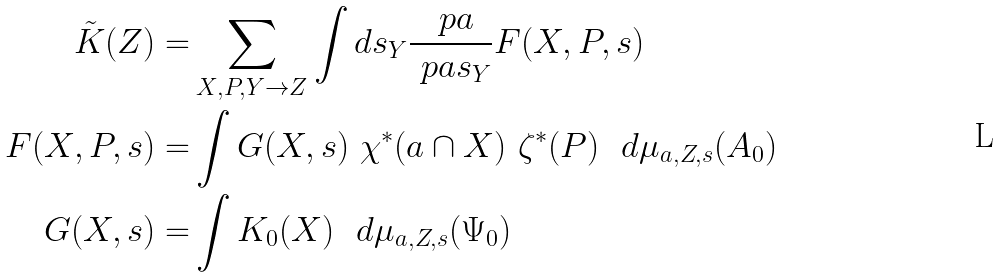Convert formula to latex. <formula><loc_0><loc_0><loc_500><loc_500>\tilde { K } ( Z ) = & \sum _ { X , P , Y \to Z } \int d s _ { Y } \frac { \ p a } { \ p a s _ { Y } } F ( X , P , s ) \\ F ( X , P , s ) = & \int G ( X , s ) \ \chi ^ { * } ( \L a \cap X ) \ \zeta ^ { * } ( P ) \ \ d \mu _ { \L a , Z , s } ( A _ { 0 } ) \\ G ( X , s ) = & \int K _ { 0 } ( X ) \ \ d \mu _ { \L a , Z , s } ( \Psi _ { 0 } ) \ \\</formula> 